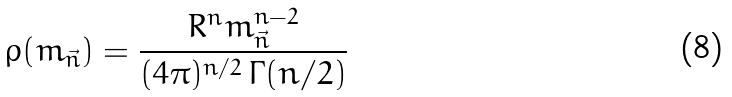Convert formula to latex. <formula><loc_0><loc_0><loc_500><loc_500>\rho ( m _ { \vec { n } } ) = { \frac { R ^ { n } m _ { \vec { n } } ^ { n - 2 } } { ( 4 \pi ) ^ { n / 2 } \, \Gamma ( n / 2 ) } }</formula> 